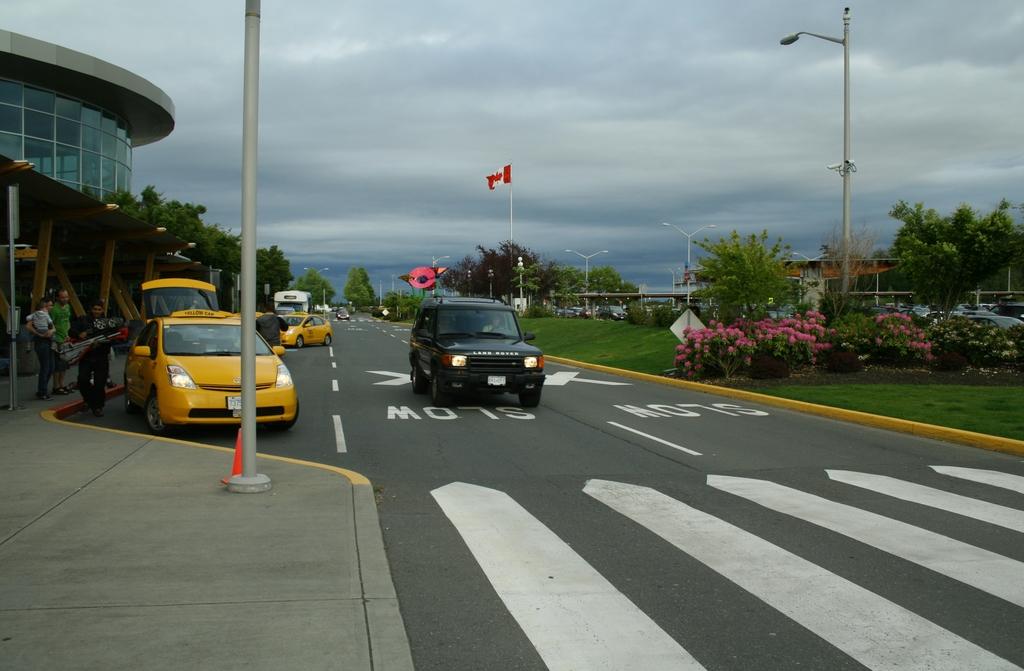Should they go slow or fast?
Offer a very short reply. Slow. What speed should they go?
Provide a succinct answer. Slow. 